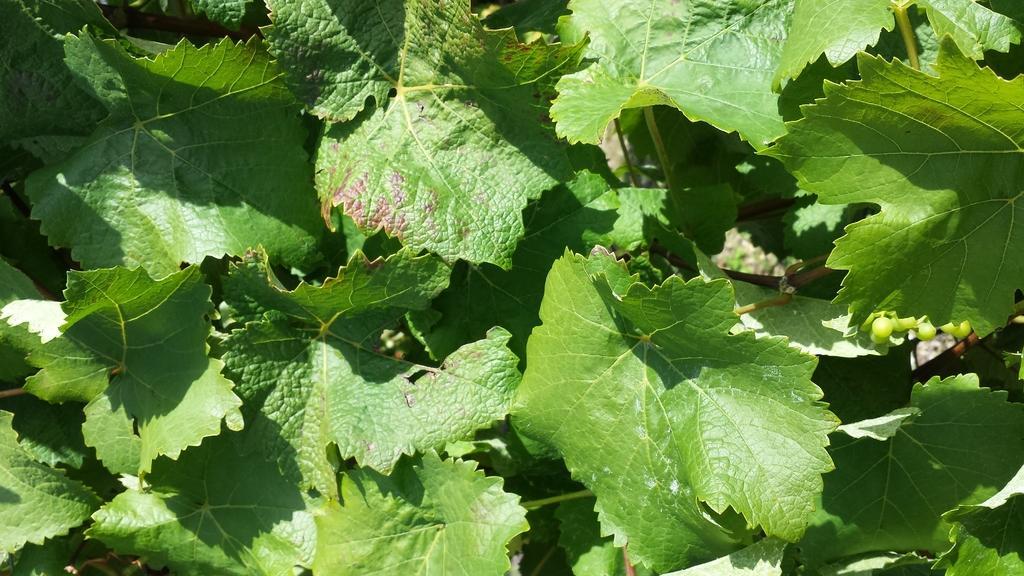Could you give a brief overview of what you see in this image? In this picture we can see leaves. 